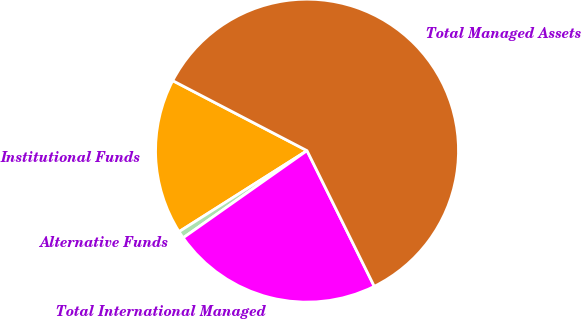<chart> <loc_0><loc_0><loc_500><loc_500><pie_chart><fcel>Institutional Funds<fcel>Alternative Funds<fcel>Total International Managed<fcel>Total Managed Assets<nl><fcel>16.63%<fcel>0.78%<fcel>22.56%<fcel>60.03%<nl></chart> 